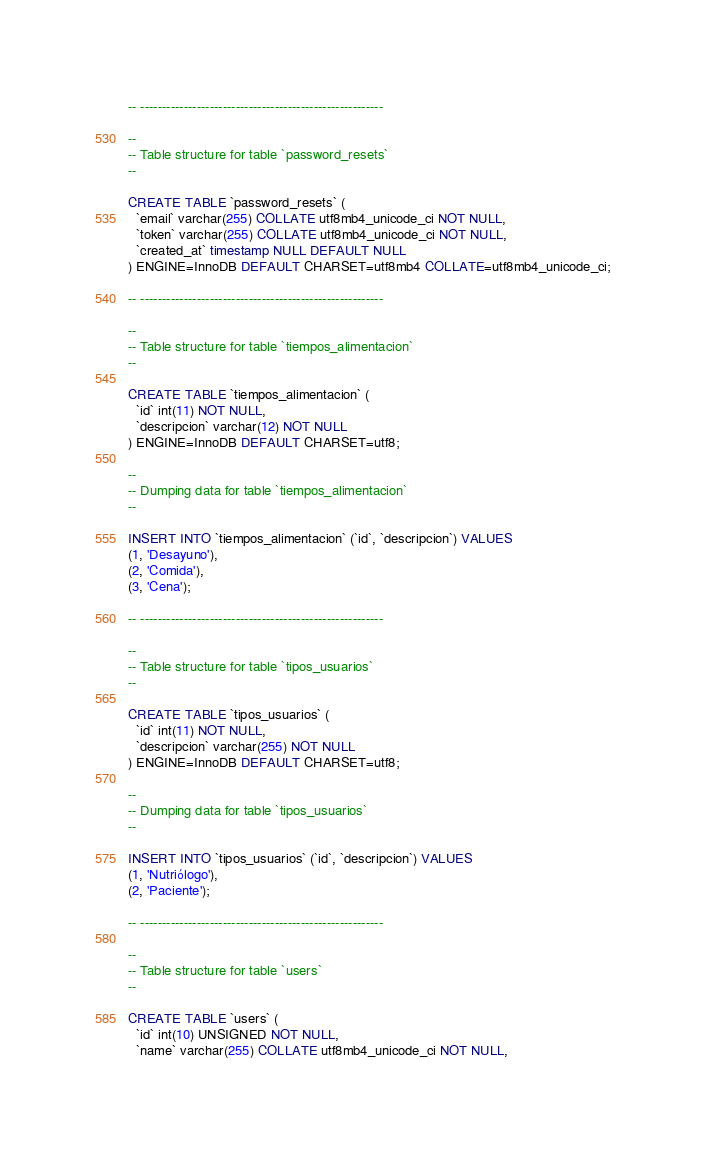Convert code to text. <code><loc_0><loc_0><loc_500><loc_500><_SQL_>
-- --------------------------------------------------------

--
-- Table structure for table `password_resets`
--

CREATE TABLE `password_resets` (
  `email` varchar(255) COLLATE utf8mb4_unicode_ci NOT NULL,
  `token` varchar(255) COLLATE utf8mb4_unicode_ci NOT NULL,
  `created_at` timestamp NULL DEFAULT NULL
) ENGINE=InnoDB DEFAULT CHARSET=utf8mb4 COLLATE=utf8mb4_unicode_ci;

-- --------------------------------------------------------

--
-- Table structure for table `tiempos_alimentacion`
--

CREATE TABLE `tiempos_alimentacion` (
  `id` int(11) NOT NULL,
  `descripcion` varchar(12) NOT NULL
) ENGINE=InnoDB DEFAULT CHARSET=utf8;

--
-- Dumping data for table `tiempos_alimentacion`
--

INSERT INTO `tiempos_alimentacion` (`id`, `descripcion`) VALUES
(1, 'Desayuno'),
(2, 'Comida'),
(3, 'Cena');

-- --------------------------------------------------------

--
-- Table structure for table `tipos_usuarios`
--

CREATE TABLE `tipos_usuarios` (
  `id` int(11) NOT NULL,
  `descripcion` varchar(255) NOT NULL
) ENGINE=InnoDB DEFAULT CHARSET=utf8;

--
-- Dumping data for table `tipos_usuarios`
--

INSERT INTO `tipos_usuarios` (`id`, `descripcion`) VALUES
(1, 'Nutriólogo'),
(2, 'Paciente');

-- --------------------------------------------------------

--
-- Table structure for table `users`
--

CREATE TABLE `users` (
  `id` int(10) UNSIGNED NOT NULL,
  `name` varchar(255) COLLATE utf8mb4_unicode_ci NOT NULL,</code> 